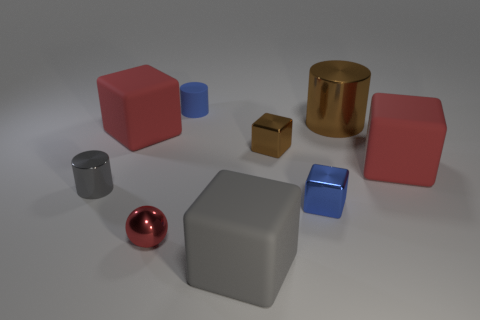Are there any other things that are the same shape as the small red object?
Provide a succinct answer. No. Is the shape of the big brown object the same as the gray thing that is on the left side of the blue rubber object?
Make the answer very short. Yes. What is the size of the object that is in front of the brown cube and on the left side of the tiny red shiny sphere?
Offer a very short reply. Small. The tiny matte object has what shape?
Ensure brevity in your answer.  Cylinder. There is a tiny metal thing that is behind the small gray metallic cylinder; are there any tiny blue rubber cylinders that are in front of it?
Your response must be concise. No. There is a matte block that is in front of the small gray object; how many blue things are to the right of it?
Your response must be concise. 1. There is a red ball that is the same size as the blue shiny object; what material is it?
Give a very brief answer. Metal. Do the large red rubber thing that is left of the small blue metallic object and the big gray object have the same shape?
Provide a short and direct response. Yes. Are there more large gray cubes in front of the big cylinder than red metallic spheres left of the red sphere?
Provide a short and direct response. Yes. How many small brown things have the same material as the red ball?
Your answer should be compact. 1. 